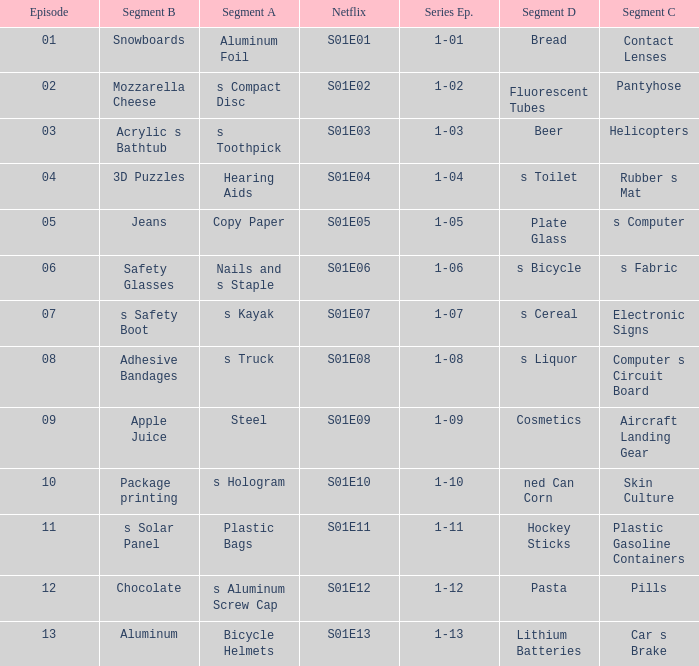Write the full table. {'header': ['Episode', 'Segment B', 'Segment A', 'Netflix', 'Series Ep.', 'Segment D', 'Segment C'], 'rows': [['01', 'Snowboards', 'Aluminum Foil', 'S01E01', '1-01', 'Bread', 'Contact Lenses'], ['02', 'Mozzarella Cheese', 's Compact Disc', 'S01E02', '1-02', 'Fluorescent Tubes', 'Pantyhose'], ['03', 'Acrylic s Bathtub', 's Toothpick', 'S01E03', '1-03', 'Beer', 'Helicopters'], ['04', '3D Puzzles', 'Hearing Aids', 'S01E04', '1-04', 's Toilet', 'Rubber s Mat'], ['05', 'Jeans', 'Copy Paper', 'S01E05', '1-05', 'Plate Glass', 's Computer'], ['06', 'Safety Glasses', 'Nails and s Staple', 'S01E06', '1-06', 's Bicycle', 's Fabric'], ['07', 's Safety Boot', 's Kayak', 'S01E07', '1-07', 's Cereal', 'Electronic Signs'], ['08', 'Adhesive Bandages', 's Truck', 'S01E08', '1-08', 's Liquor', 'Computer s Circuit Board'], ['09', 'Apple Juice', 'Steel', 'S01E09', '1-09', 'Cosmetics', 'Aircraft Landing Gear'], ['10', 'Package printing', 's Hologram', 'S01E10', '1-10', 'ned Can Corn', 'Skin Culture'], ['11', 's Solar Panel', 'Plastic Bags', 'S01E11', '1-11', 'Hockey Sticks', 'Plastic Gasoline Containers'], ['12', 'Chocolate', 's Aluminum Screw Cap', 'S01E12', '1-12', 'Pasta', 'Pills'], ['13', 'Aluminum', 'Bicycle Helmets', 'S01E13', '1-13', 'Lithium Batteries', 'Car s Brake']]} For a segment D of pasta, what is the segment B? Chocolate. 